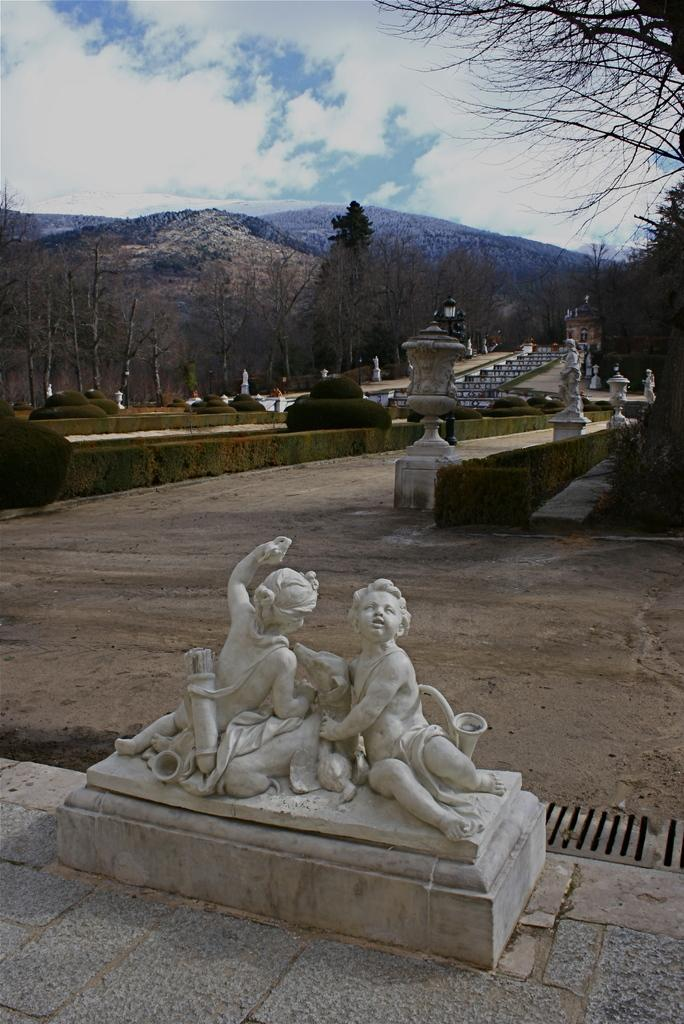What type of structures can be seen in the image? There are statues in the image. What type of vegetation is present in the image? There are plants and trees in the image. What type of structure is also visible in the image? There is a building in the image. What else can be seen in the image besides the statues, plants, trees, and building? There are objects in the image. What can be seen in the background of the image? Mountains and sky are visible in the background of the image. Can you tell me how many wax giraffes are present in the image? There are no wax giraffes present in the image. What type of car can be seen driving through the mountains in the image? There is no car visible in the image; only statues, plants, trees, a building, objects, mountains, and sky are present. 